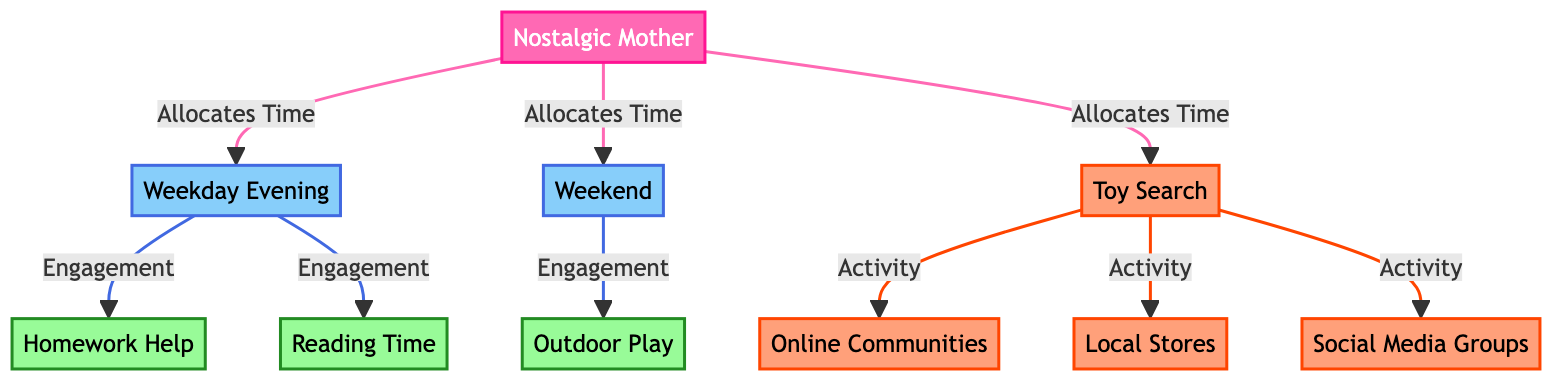What are the three main time allocation categories for the nostalgic mother? The diagram shows three distinct time allocation categories connected to the node representing the nostalgic mother: Weekday Evening, Weekend, and Toy Search.
Answer: Weekday Evening, Weekend, Toy Search How many activities does the nostalgic mother engage in during the weekday evening? The weekday evening node connects to two specific activities: Homework Help and Reading Time. Counting these connections yields a total of two activities.
Answer: 2 What type of stores does the nostalgic mother search for toys? The diagram features three types of activities related to the toy search: Online Communities, Local Stores, and Social Media Groups. Local Stores is one of those types, indicating where the mother searches for toys.
Answer: Local Stores Which activity is associated with weekend time? The weekend time node connects to one specific activity: Outdoor Play. This indicates that the nostalgic mother engages in outdoor play during her weekend time allocation.
Answer: Outdoor Play What color represents the nostalgic mother in the diagram? The node representing the nostalgic mother is colored pink, specifically with the applied class definitions for the mother, using fill color #FF69B4.
Answer: Pink Which engagement occurs in the weekday evening time allocation? The weekday evening time allocation has two engagements: Homework Help and Reading Time. Both are connected to the Weekday Evening node, indicating their relevance to that timing.
Answer: Homework Help, Reading Time How many total search activities are listed in the diagram? The diagram illustrates four distinct search activities related to toy search: Online Communities, Local Stores, Social Media Groups, and Toy Search itself. Counting all these yields a total of four search activities.
Answer: 4 In what time allocation does the nostalgic mother engage in reading? The engagement in reading is specified under the Weekday Evening time allocation, confirming that it occurs specifically during this time.
Answer: Weekday Evening Which nodes are connected directly to the Toy Search node? The Toy Search node connects directly to three different activities: Online Communities, Local Stores, and Social Media Groups, indicating where the mother seeks out toys.
Answer: Online Communities, Local Stores, Social Media Groups 